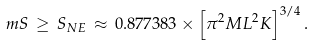<formula> <loc_0><loc_0><loc_500><loc_500>\ m { S \, \geq \, S _ { N E } \, \approx \, 0 . 8 7 7 3 8 3 \times \left [ \pi ^ { 2 } M L ^ { 2 } K \right ] ^ { 3 / 4 } . }</formula> 